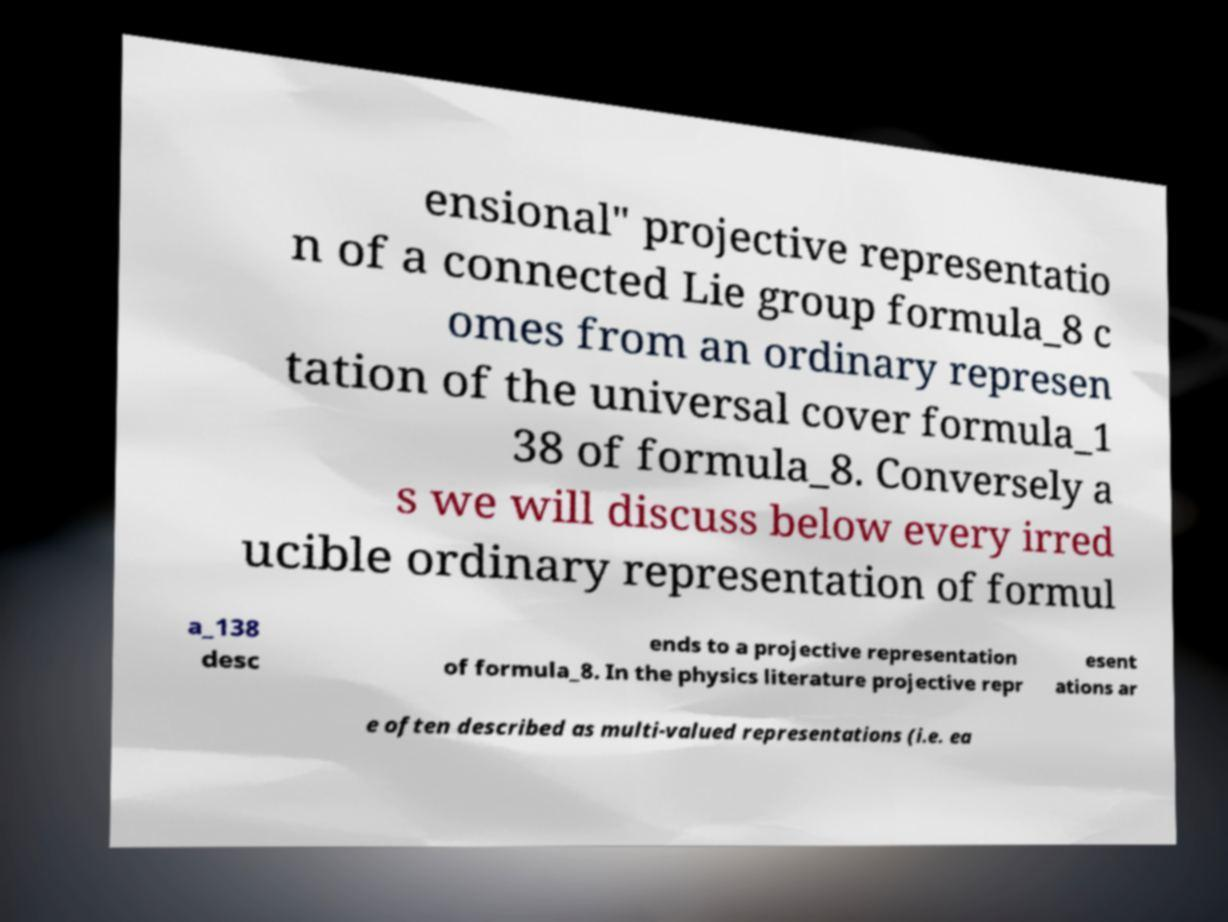What messages or text are displayed in this image? I need them in a readable, typed format. ensional" projective representatio n of a connected Lie group formula_8 c omes from an ordinary represen tation of the universal cover formula_1 38 of formula_8. Conversely a s we will discuss below every irred ucible ordinary representation of formul a_138 desc ends to a projective representation of formula_8. In the physics literature projective repr esent ations ar e often described as multi-valued representations (i.e. ea 